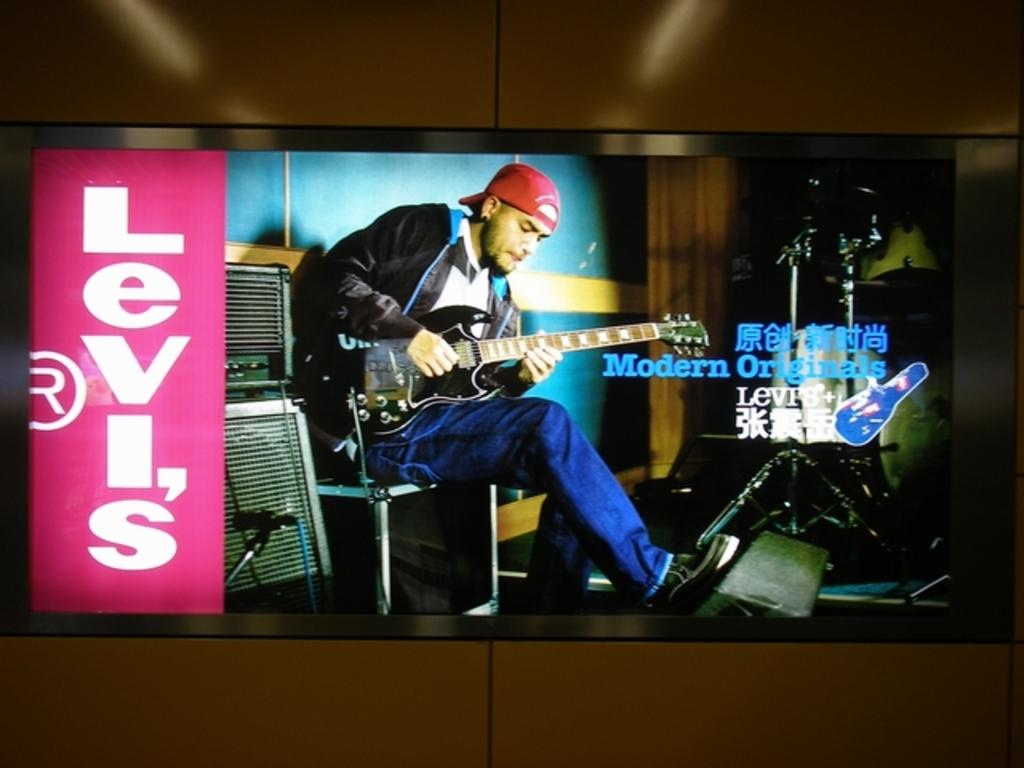<image>
Write a terse but informative summary of the picture. A flat screen TV is showing a guitar player and says Levi's Modern Originals. 